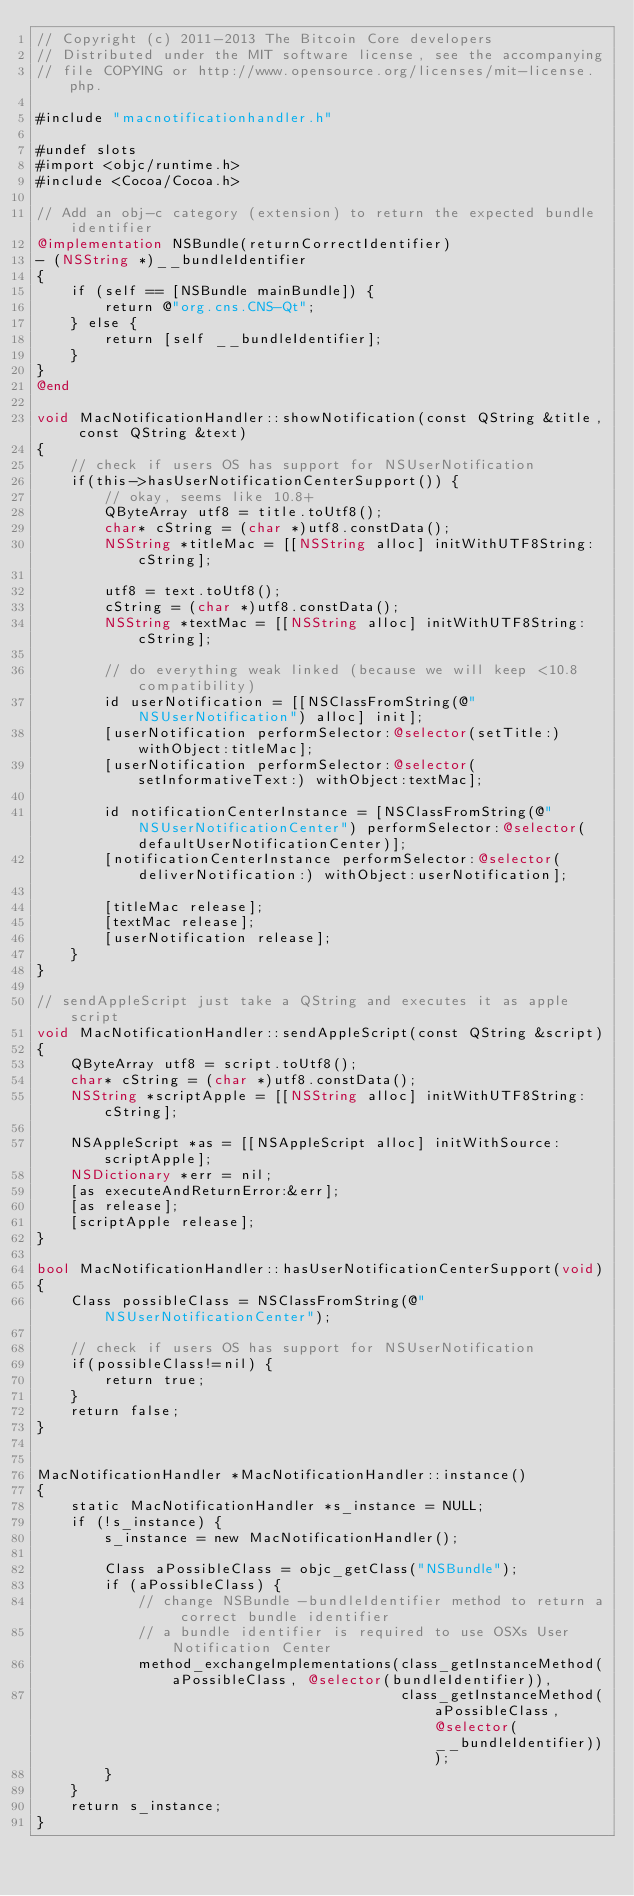<code> <loc_0><loc_0><loc_500><loc_500><_ObjectiveC_>// Copyright (c) 2011-2013 The Bitcoin Core developers
// Distributed under the MIT software license, see the accompanying
// file COPYING or http://www.opensource.org/licenses/mit-license.php.

#include "macnotificationhandler.h"

#undef slots
#import <objc/runtime.h>
#include <Cocoa/Cocoa.h>

// Add an obj-c category (extension) to return the expected bundle identifier
@implementation NSBundle(returnCorrectIdentifier)
- (NSString *)__bundleIdentifier
{
    if (self == [NSBundle mainBundle]) {
        return @"org.cns.CNS-Qt";
    } else {
        return [self __bundleIdentifier];
    }
}
@end

void MacNotificationHandler::showNotification(const QString &title, const QString &text)
{
    // check if users OS has support for NSUserNotification
    if(this->hasUserNotificationCenterSupport()) {
        // okay, seems like 10.8+
        QByteArray utf8 = title.toUtf8();
        char* cString = (char *)utf8.constData();
        NSString *titleMac = [[NSString alloc] initWithUTF8String:cString];

        utf8 = text.toUtf8();
        cString = (char *)utf8.constData();
        NSString *textMac = [[NSString alloc] initWithUTF8String:cString];

        // do everything weak linked (because we will keep <10.8 compatibility)
        id userNotification = [[NSClassFromString(@"NSUserNotification") alloc] init];
        [userNotification performSelector:@selector(setTitle:) withObject:titleMac];
        [userNotification performSelector:@selector(setInformativeText:) withObject:textMac];

        id notificationCenterInstance = [NSClassFromString(@"NSUserNotificationCenter") performSelector:@selector(defaultUserNotificationCenter)];
        [notificationCenterInstance performSelector:@selector(deliverNotification:) withObject:userNotification];

        [titleMac release];
        [textMac release];
        [userNotification release];
    }
}

// sendAppleScript just take a QString and executes it as apple script
void MacNotificationHandler::sendAppleScript(const QString &script)
{
    QByteArray utf8 = script.toUtf8();
    char* cString = (char *)utf8.constData();
    NSString *scriptApple = [[NSString alloc] initWithUTF8String:cString];

    NSAppleScript *as = [[NSAppleScript alloc] initWithSource:scriptApple];
    NSDictionary *err = nil;
    [as executeAndReturnError:&err];
    [as release];
    [scriptApple release];
}

bool MacNotificationHandler::hasUserNotificationCenterSupport(void)
{
    Class possibleClass = NSClassFromString(@"NSUserNotificationCenter");

    // check if users OS has support for NSUserNotification
    if(possibleClass!=nil) {
        return true;
    }
    return false;
}


MacNotificationHandler *MacNotificationHandler::instance()
{
    static MacNotificationHandler *s_instance = NULL;
    if (!s_instance) {
        s_instance = new MacNotificationHandler();
        
        Class aPossibleClass = objc_getClass("NSBundle");
        if (aPossibleClass) {
            // change NSBundle -bundleIdentifier method to return a correct bundle identifier
            // a bundle identifier is required to use OSXs User Notification Center
            method_exchangeImplementations(class_getInstanceMethod(aPossibleClass, @selector(bundleIdentifier)),
                                           class_getInstanceMethod(aPossibleClass, @selector(__bundleIdentifier)));
        }
    }
    return s_instance;
}
</code> 